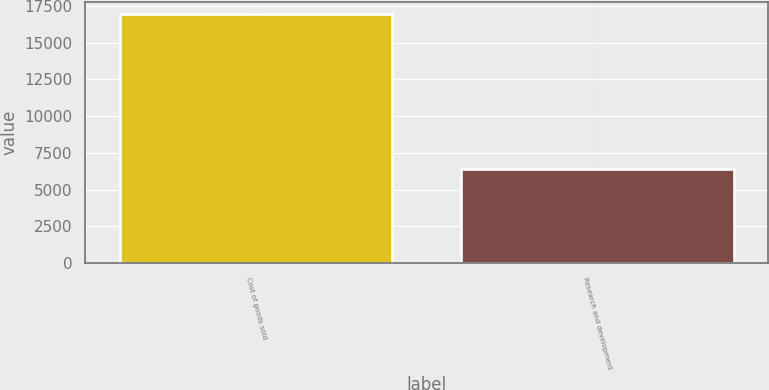Convert chart to OTSL. <chart><loc_0><loc_0><loc_500><loc_500><bar_chart><fcel>Cost of goods sold<fcel>Research and development<nl><fcel>16937<fcel>6436<nl></chart> 